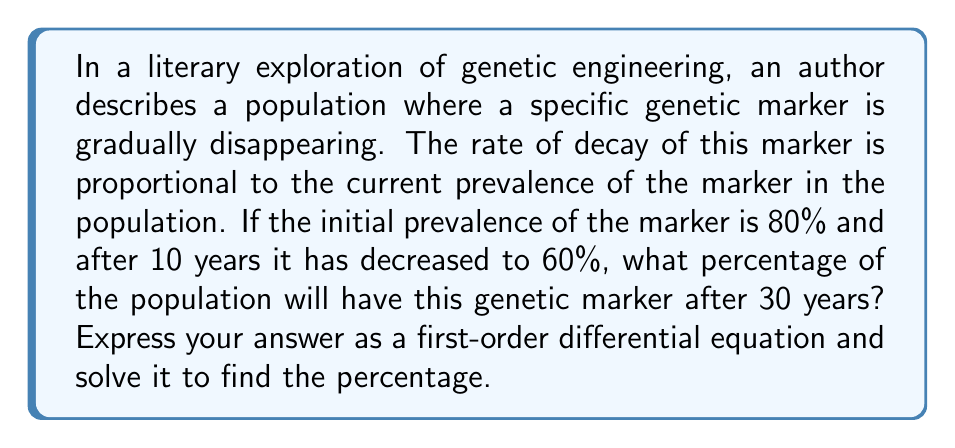Solve this math problem. Let's approach this problem step-by-step:

1) Let $P(t)$ be the percentage of the population with the genetic marker at time $t$ (in years).

2) The rate of decay is proportional to the current prevalence, which can be expressed as:

   $$\frac{dP}{dt} = -kP$$

   where $k$ is the decay constant.

3) This is a separable first-order differential equation. We can solve it as follows:

   $$\frac{dP}{P} = -k dt$$

   $$\int \frac{dP}{P} = -k \int dt$$

   $$\ln|P| = -kt + C$$

   $$P = e^{-kt + C} = Ae^{-kt}$$

   where $A = e^C$ is a constant.

4) We know two points: 
   At $t=0$, $P(0) = 80\%$
   At $t=10$, $P(10) = 60\%$

5) Using $P(0) = 80\%$:
   
   $80 = Ae^{-k(0)} = A$

6) Using $P(10) = 60\%$:
   
   $60 = 80e^{-k(10)}$

   $\frac{60}{80} = e^{-10k}$

   $\ln(\frac{3}{4}) = -10k$

   $k = -\frac{1}{10}\ln(\frac{3}{4}) \approx 0.02877$

7) Now we have the full equation:

   $P(t) = 80e^{-0.02877t}$

8) To find $P(30)$:

   $P(30) = 80e^{-0.02877(30)} \approx 33.85\%$
Answer: After 30 years, approximately 33.85% of the population will have the genetic marker. 